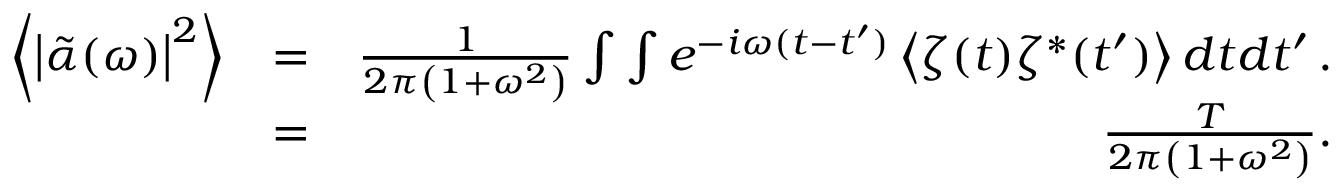Convert formula to latex. <formula><loc_0><loc_0><loc_500><loc_500>\begin{array} { r l r } { \left \langle \left | \tilde { \alpha } ( \omega ) \right | ^ { 2 } \right \rangle } & { = } & { \frac { 1 } { 2 \pi \left ( 1 + \omega ^ { 2 } \right ) } \int \int e ^ { - i \omega ( t - t ^ { \prime } ) } \left \langle \zeta ( t ) \zeta ^ { * } ( t ^ { \prime } ) \right \rangle d t d t ^ { \prime } \, . } \\ & { = } & { \frac { T } { 2 \pi \left ( 1 + \omega ^ { 2 } \right ) } . } \end{array}</formula> 